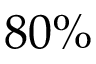<formula> <loc_0><loc_0><loc_500><loc_500>8 0 \%</formula> 